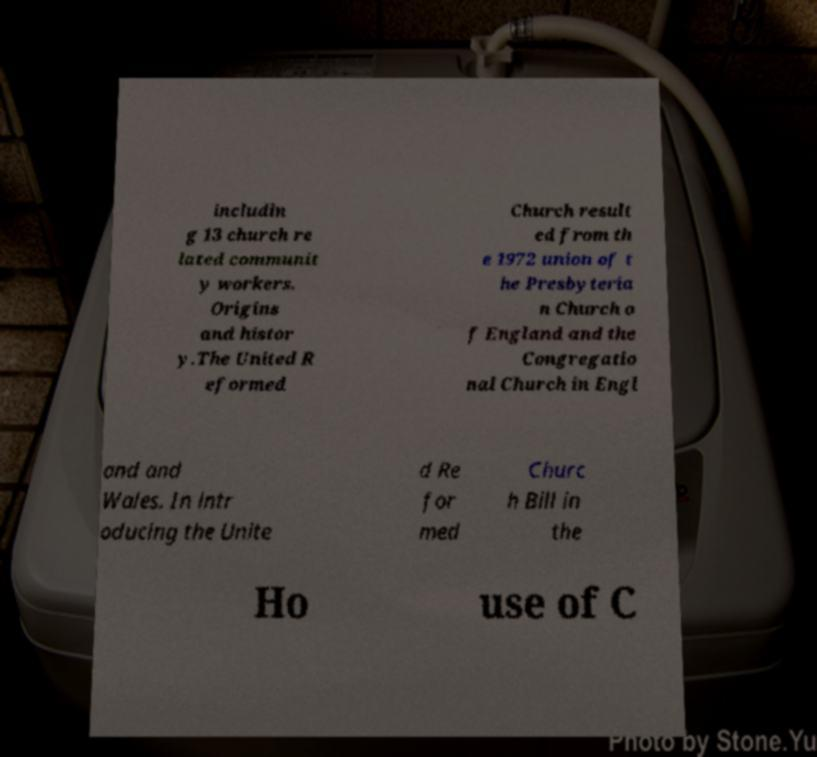Could you extract and type out the text from this image? includin g 13 church re lated communit y workers. Origins and histor y.The United R eformed Church result ed from th e 1972 union of t he Presbyteria n Church o f England and the Congregatio nal Church in Engl and and Wales. In intr oducing the Unite d Re for med Churc h Bill in the Ho use of C 